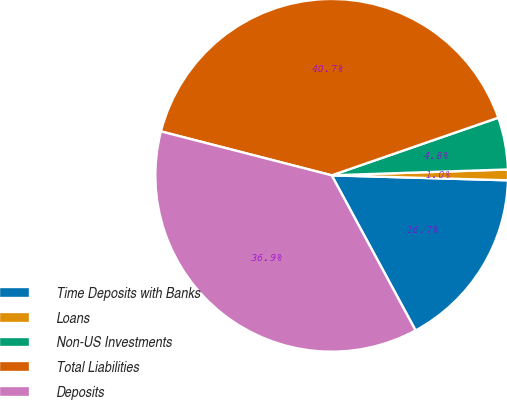Convert chart. <chart><loc_0><loc_0><loc_500><loc_500><pie_chart><fcel>Time Deposits with Banks<fcel>Loans<fcel>Non-US Investments<fcel>Total Liabilities<fcel>Deposits<nl><fcel>16.66%<fcel>0.98%<fcel>4.77%<fcel>40.69%<fcel>36.9%<nl></chart> 